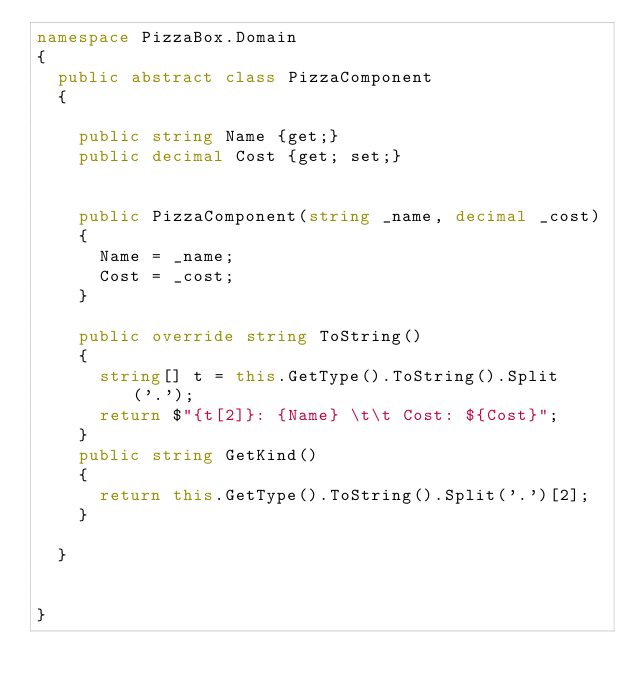<code> <loc_0><loc_0><loc_500><loc_500><_C#_>namespace PizzaBox.Domain
{
  public abstract class PizzaComponent
  {

    public string Name {get;}
    public decimal Cost {get; set;}
    

    public PizzaComponent(string _name, decimal _cost)
    {
      Name = _name;
      Cost = _cost;
    }

    public override string ToString()
    {
      string[] t = this.GetType().ToString().Split('.');
      return $"{t[2]}: {Name} \t\t Cost: ${Cost}";
    }
    public string GetKind()
    {
      return this.GetType().ToString().Split('.')[2];
    }

  }
      
    
}</code> 